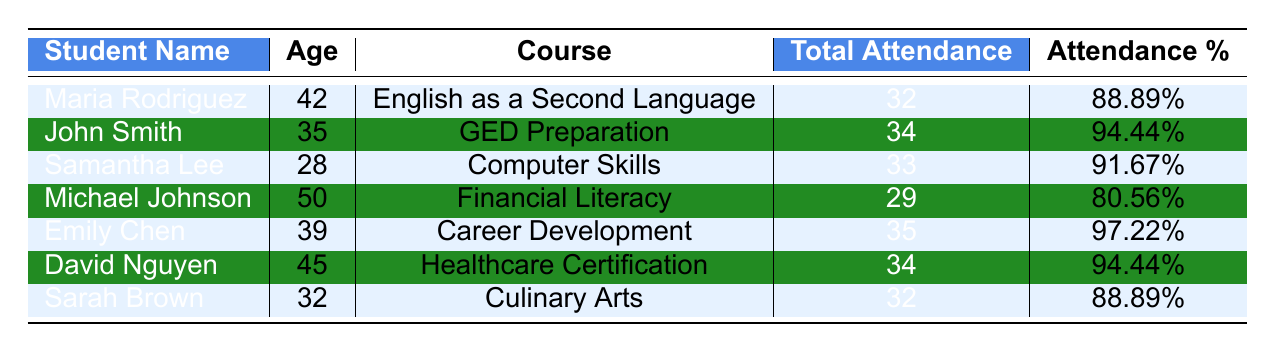What is the total attendance of Emily Chen? The table lists the total attendance for each student. Looking at Emily Chen's row, the total attendance is specified as 35.
Answer: 35 Who has the highest attendance percentage? By comparing the attendance percentages listed in the table, I see that Emily Chen has the highest percentage at 97.22%.
Answer: 97.22% What is the average attendance percentage of all students? To find the average, sum the attendance percentages: (88.89 + 94.44 + 91.67 + 80.56 + 97.22 + 94.44 + 88.89) = 525.11. Divide by the number of students (7): 525.11 / 7 = 75.01 (rounded), which gives an average attendance percentage of approximately 90.01%.
Answer: 90.01% Did Michael Johnson attend more classes than Maria Rodriguez? Michael Johnson's total attendance is 29, while Maria Rodriguez's total is 32. Since 29 is less than 32, Michael Johnson attended fewer classes.
Answer: No What is the difference in total attendance between John Smith and David Nguyen? John Smith's total attendance is 34, and David Nguyen's total is also 34. The difference is calculated as 34 - 34 = 0.
Answer: 0 Which student is enrolled in Computer Skills? By referring to the course column, I can see that Samantha Lee is the student enrolled in Computer Skills.
Answer: Samantha Lee How many students have an attendance percentage above 90%? From the table, the following students have percentages above 90%: John Smith (94.44%), Samantha Lee (91.67%), Emily Chen (97.22%), and David Nguyen (94.44%). In total, there are four students with attendance above 90%.
Answer: 4 What is the total attendance for students in the "English as a Second Language" course? Maria Rodriguez is the only student listed in the course "English as a Second Language," with a total attendance of 32. Therefore, her total attendance is also the total for this course.
Answer: 32 Which courses have a total attendance less than 30? The table shows that the only student with a total attendance of less than 30 is Michael Johnson, who is taking "Financial Literacy" with 29 total attendance.
Answer: Financial Literacy How many students are aged 39 or younger? The ages of the students are: Maria Rodriguez (42), John Smith (35), Samantha Lee (28), Michael Johnson (50), Emily Chen (39), David Nguyen (45), and Sarah Brown (32). The students aged 39 or younger are John Smith, Samantha Lee, Emily Chen, and Sarah Brown, totaling four students.
Answer: 4 Is there any student with exactly 32 total attendance? Looking through the total attendance values, I can see that both Maria Rodriguez and Sarah Brown have a total attendance of 32. Therefore, there are indeed two students with exactly 32 total attendance.
Answer: Yes 